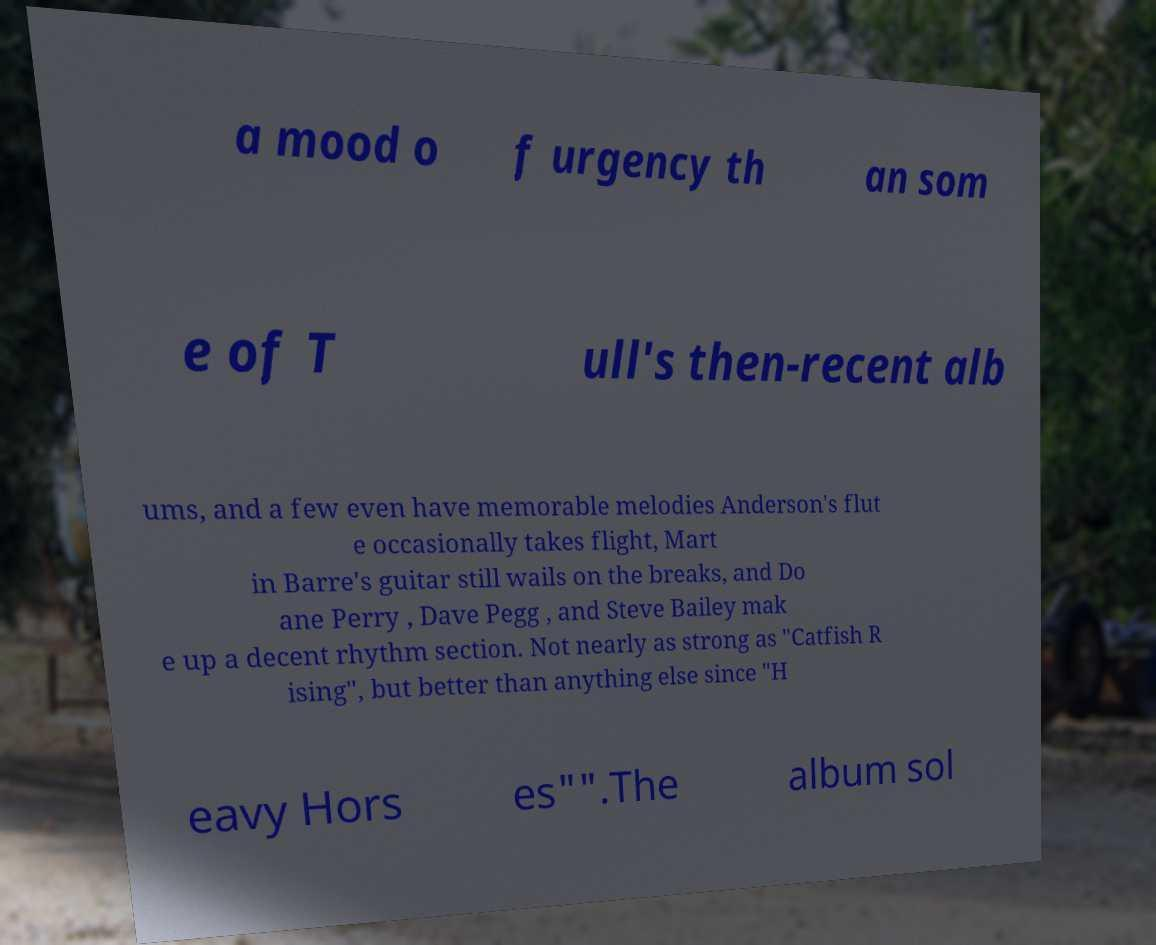I need the written content from this picture converted into text. Can you do that? a mood o f urgency th an som e of T ull's then-recent alb ums, and a few even have memorable melodies Anderson's flut e occasionally takes flight, Mart in Barre's guitar still wails on the breaks, and Do ane Perry , Dave Pegg , and Steve Bailey mak e up a decent rhythm section. Not nearly as strong as "Catfish R ising", but better than anything else since "H eavy Hors es"".The album sol 